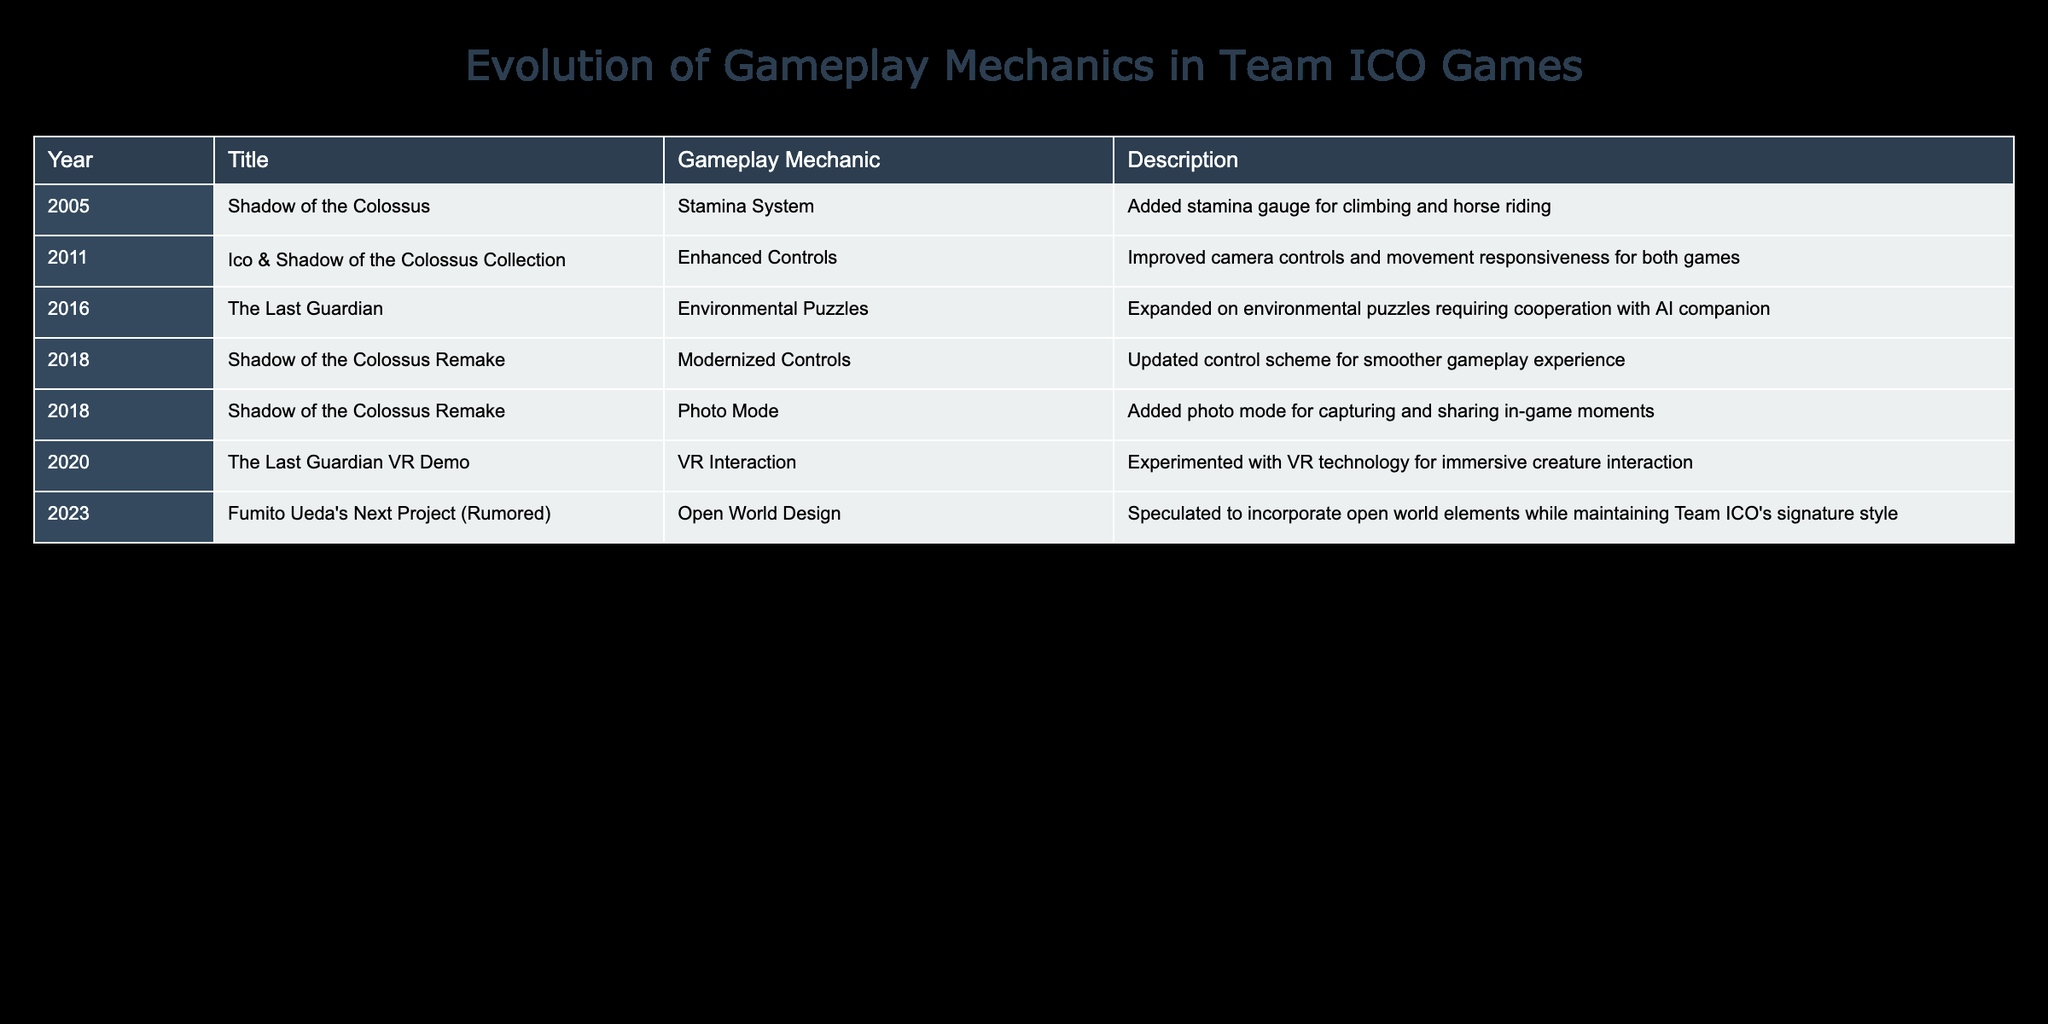What new gameplay mechanic was introduced in 2005? The table shows that in 2005, "Shadow of the Colossus" introduced the Stamina System, which added a stamina gauge for climbing and horse riding.
Answer: Stamina System Which game had enhanced controls as a gameplay mechanic? According to the table, the "Ico & Shadow of the Colossus Collection" released in 2011 featured Enhanced Controls, which improved camera controls and movement responsiveness for both games.
Answer: Ico & Shadow of the Colossus Collection How many years passed between the release of "Shadow of the Colossus" and "The Last Guardian"? "Shadow of the Colossus" was released in 2005 and "The Last Guardian" was released in 2016. The difference between 2016 and 2005 is 11 years.
Answer: 11 years Was a photo mode added in the original "Shadow of the Colossus"? The table indicates that the photo mode was added in the 2018 "Shadow of the Colossus Remake," not in the original game. Therefore, the answer is no.
Answer: No Which title features environmental puzzles involving cooperation with an AI companion? The table specifies that "The Last Guardian," released in 2016, expanded on environmental puzzles that required cooperation with the AI companion.
Answer: The Last Guardian What is the trend in gameplay mechanic innovations from 2005 to 2023? By analyzing the table, it appears that gameplay mechanics have evolved from stamina systems and control enhancements to more complex elements like environmental puzzles, modernized controls, and open world design, indicating increased complexity and interactivity over time.
Answer: Increased complexity In how many titles was an open world design speculated? The table only mentions that Fumito Ueda's next project (rumored) for 2023 is speculated to incorporate open world design, meaning it is only mentioned for this one title.
Answer: One title What significant change was made to "Shadow of the Colossus" in its 2018 remake? The table indicates that the 2018 "Shadow of the Colossus Remake" introduced both Modernized Controls for smoother gameplay and a Photo Mode to capture in-game moments.
Answer: Modernized Controls and Photo Mode Which year saw the introduction of VR interaction as a gameplay mechanic? The table shows that the "The Last Guardian VR Demo," which introduced VR interaction, was released in 2020.
Answer: 2020 